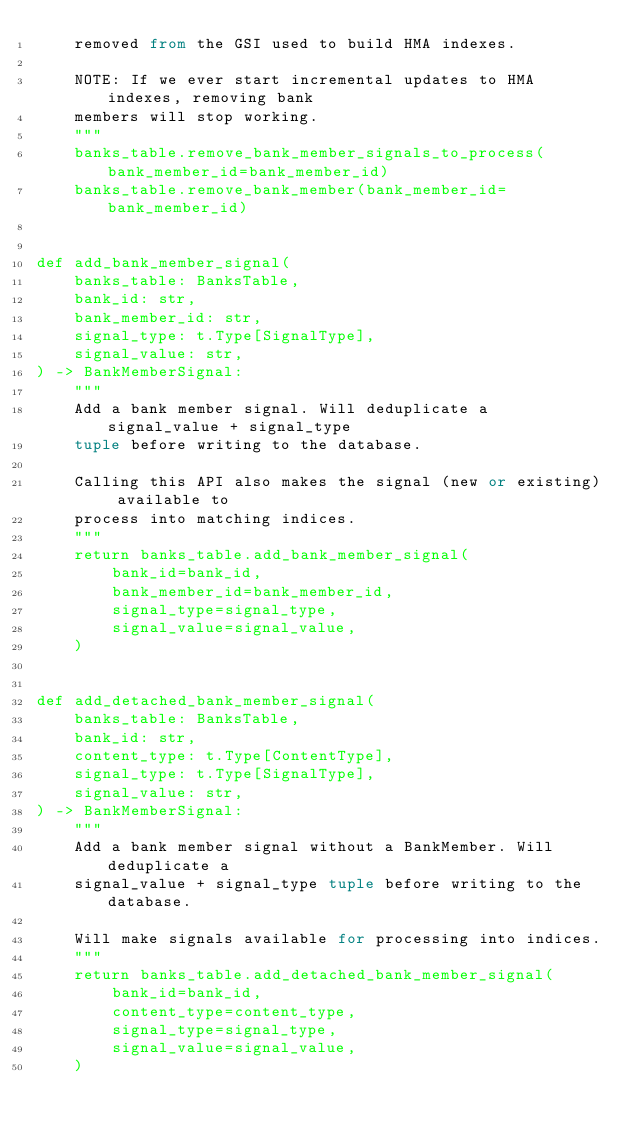<code> <loc_0><loc_0><loc_500><loc_500><_Python_>    removed from the GSI used to build HMA indexes.

    NOTE: If we ever start incremental updates to HMA indexes, removing bank
    members will stop working.
    """
    banks_table.remove_bank_member_signals_to_process(bank_member_id=bank_member_id)
    banks_table.remove_bank_member(bank_member_id=bank_member_id)


def add_bank_member_signal(
    banks_table: BanksTable,
    bank_id: str,
    bank_member_id: str,
    signal_type: t.Type[SignalType],
    signal_value: str,
) -> BankMemberSignal:
    """
    Add a bank member signal. Will deduplicate a signal_value + signal_type
    tuple before writing to the database.

    Calling this API also makes the signal (new or existing) available to
    process into matching indices.
    """
    return banks_table.add_bank_member_signal(
        bank_id=bank_id,
        bank_member_id=bank_member_id,
        signal_type=signal_type,
        signal_value=signal_value,
    )


def add_detached_bank_member_signal(
    banks_table: BanksTable,
    bank_id: str,
    content_type: t.Type[ContentType],
    signal_type: t.Type[SignalType],
    signal_value: str,
) -> BankMemberSignal:
    """
    Add a bank member signal without a BankMember. Will deduplicate a
    signal_value + signal_type tuple before writing to the database.

    Will make signals available for processing into indices.
    """
    return banks_table.add_detached_bank_member_signal(
        bank_id=bank_id,
        content_type=content_type,
        signal_type=signal_type,
        signal_value=signal_value,
    )
</code> 